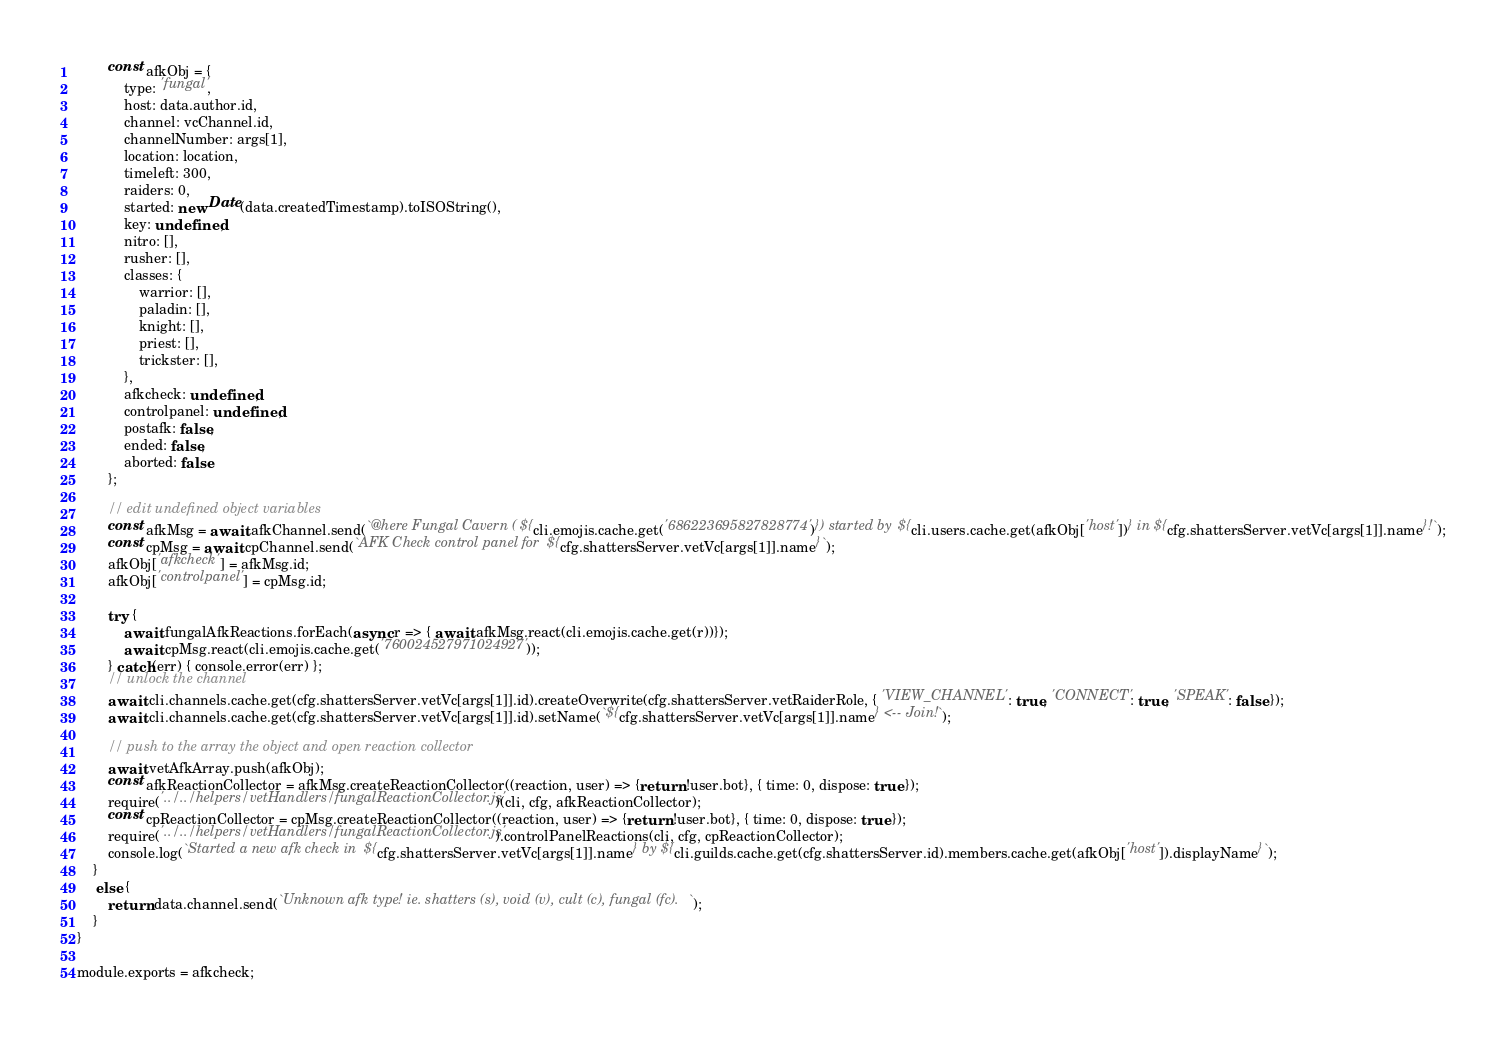<code> <loc_0><loc_0><loc_500><loc_500><_JavaScript_>		const afkObj = {
			type: 'fungal',
			host: data.author.id,
			channel: vcChannel.id,
			channelNumber: args[1],
			location: location,
			timeleft: 300,
			raiders: 0,
			started: new Date(data.createdTimestamp).toISOString(),
			key: undefined,
			nitro: [],
			rusher: [],
			classes: {
				warrior: [],
				paladin: [],
				knight: [],
				priest: [],
				trickster: [],
			},
			afkcheck: undefined,
			controlpanel: undefined,
			postafk: false,
			ended: false,
			aborted: false
		};

		// edit undefined object variables
		const afkMsg = await afkChannel.send(`@here Fungal Cavern (${cli.emojis.cache.get('686223695827828774')}) started by ${cli.users.cache.get(afkObj['host'])} in ${cfg.shattersServer.vetVc[args[1]].name}!`);
		const cpMsg = await cpChannel.send(`AFK Check control panel for ${cfg.shattersServer.vetVc[args[1]].name}`);
		afkObj['afkcheck'] = afkMsg.id;
		afkObj['controlpanel'] = cpMsg.id;

		try {
			await fungalAfkReactions.forEach(async r => { await afkMsg.react(cli.emojis.cache.get(r))});
			await cpMsg.react(cli.emojis.cache.get('760024527971024927'));
		} catch(err) { console.error(err) };
		// unlock the channel
		await cli.channels.cache.get(cfg.shattersServer.vetVc[args[1]].id).createOverwrite(cfg.shattersServer.vetRaiderRole, { 'VIEW_CHANNEL': true, 'CONNECT': true, 'SPEAK': false });
		await cli.channels.cache.get(cfg.shattersServer.vetVc[args[1]].id).setName(`${cfg.shattersServer.vetVc[args[1]].name} <-- Join!`);

		// push to the array the object and open reaction collector
		await vetAfkArray.push(afkObj);
		const afkReactionCollector = afkMsg.createReactionCollector((reaction, user) => {return !user.bot}, { time: 0, dispose: true });
		require('../../helpers/vetHandlers/fungalReactionCollector.js')(cli, cfg, afkReactionCollector);
		const cpReactionCollector = cpMsg.createReactionCollector((reaction, user) => {return !user.bot}, { time: 0, dispose: true });
		require('../../helpers/vetHandlers/fungalReactionCollector.js').controlPanelReactions(cli, cfg, cpReactionCollector);
		console.log(`Started a new afk check in ${cfg.shattersServer.vetVc[args[1]].name} by ${cli.guilds.cache.get(cfg.shattersServer.id).members.cache.get(afkObj['host']).displayName}`);
	}
	 else {
		return data.channel.send(`Unknown afk type! ie. shatters (s), void (v), cult (c), fungal (fc).`);
	}
}

module.exports = afkcheck;</code> 